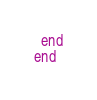Convert code to text. <code><loc_0><loc_0><loc_500><loc_500><_Ruby_>  end
end
</code> 